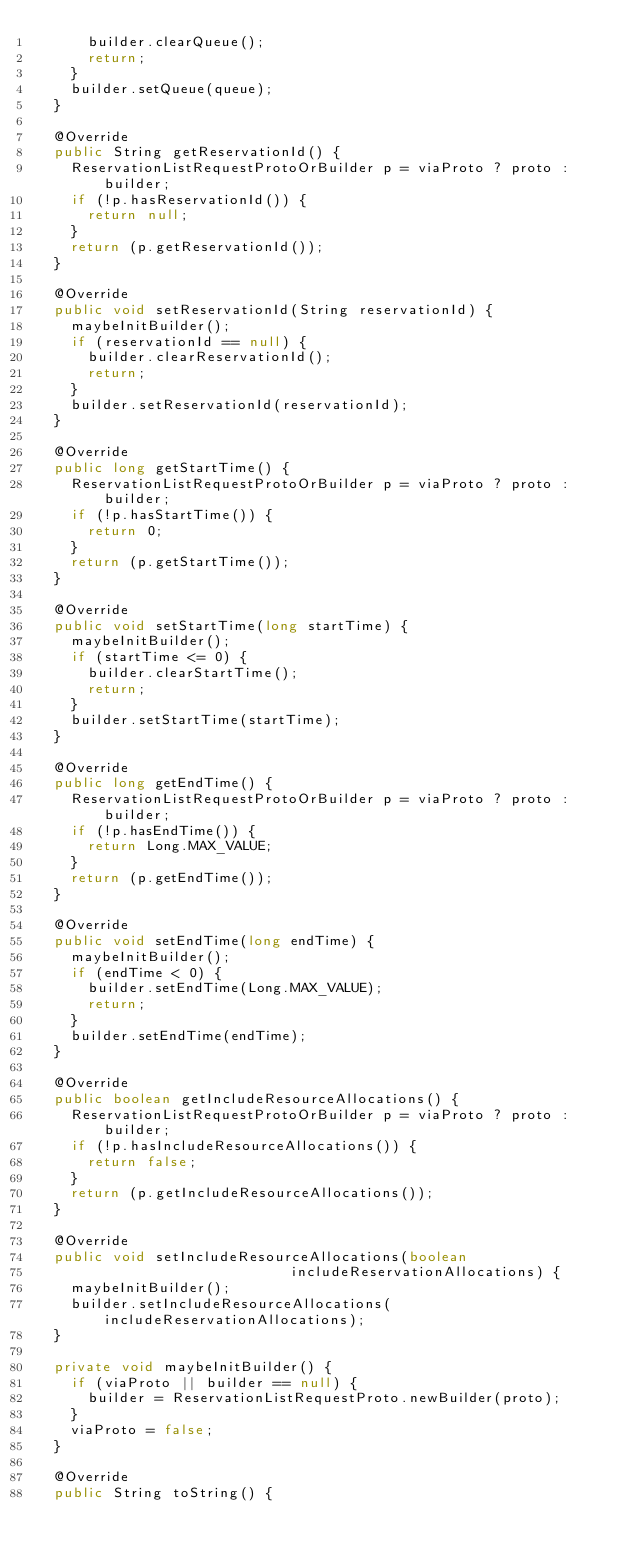Convert code to text. <code><loc_0><loc_0><loc_500><loc_500><_Java_>      builder.clearQueue();
      return;
    }
    builder.setQueue(queue);
  }

  @Override
  public String getReservationId() {
    ReservationListRequestProtoOrBuilder p = viaProto ? proto : builder;
    if (!p.hasReservationId()) {
      return null;
    }
    return (p.getReservationId());
  }

  @Override
  public void setReservationId(String reservationId) {
    maybeInitBuilder();
    if (reservationId == null) {
      builder.clearReservationId();
      return;
    }
    builder.setReservationId(reservationId);
  }

  @Override
  public long getStartTime() {
    ReservationListRequestProtoOrBuilder p = viaProto ? proto : builder;
    if (!p.hasStartTime()) {
      return 0;
    }
    return (p.getStartTime());
  }

  @Override
  public void setStartTime(long startTime) {
    maybeInitBuilder();
    if (startTime <= 0) {
      builder.clearStartTime();
      return;
    }
    builder.setStartTime(startTime);
  }

  @Override
  public long getEndTime() {
    ReservationListRequestProtoOrBuilder p = viaProto ? proto : builder;
    if (!p.hasEndTime()) {
      return Long.MAX_VALUE;
    }
    return (p.getEndTime());
  }

  @Override
  public void setEndTime(long endTime) {
    maybeInitBuilder();
    if (endTime < 0) {
      builder.setEndTime(Long.MAX_VALUE);
      return;
    }
    builder.setEndTime(endTime);
  }

  @Override
  public boolean getIncludeResourceAllocations() {
    ReservationListRequestProtoOrBuilder p = viaProto ? proto : builder;
    if (!p.hasIncludeResourceAllocations()) {
      return false;
    }
    return (p.getIncludeResourceAllocations());
  }

  @Override
  public void setIncludeResourceAllocations(boolean
                              includeReservationAllocations) {
    maybeInitBuilder();
    builder.setIncludeResourceAllocations(includeReservationAllocations);
  }

  private void maybeInitBuilder() {
    if (viaProto || builder == null) {
      builder = ReservationListRequestProto.newBuilder(proto);
    }
    viaProto = false;
  }

  @Override
  public String toString() {</code> 